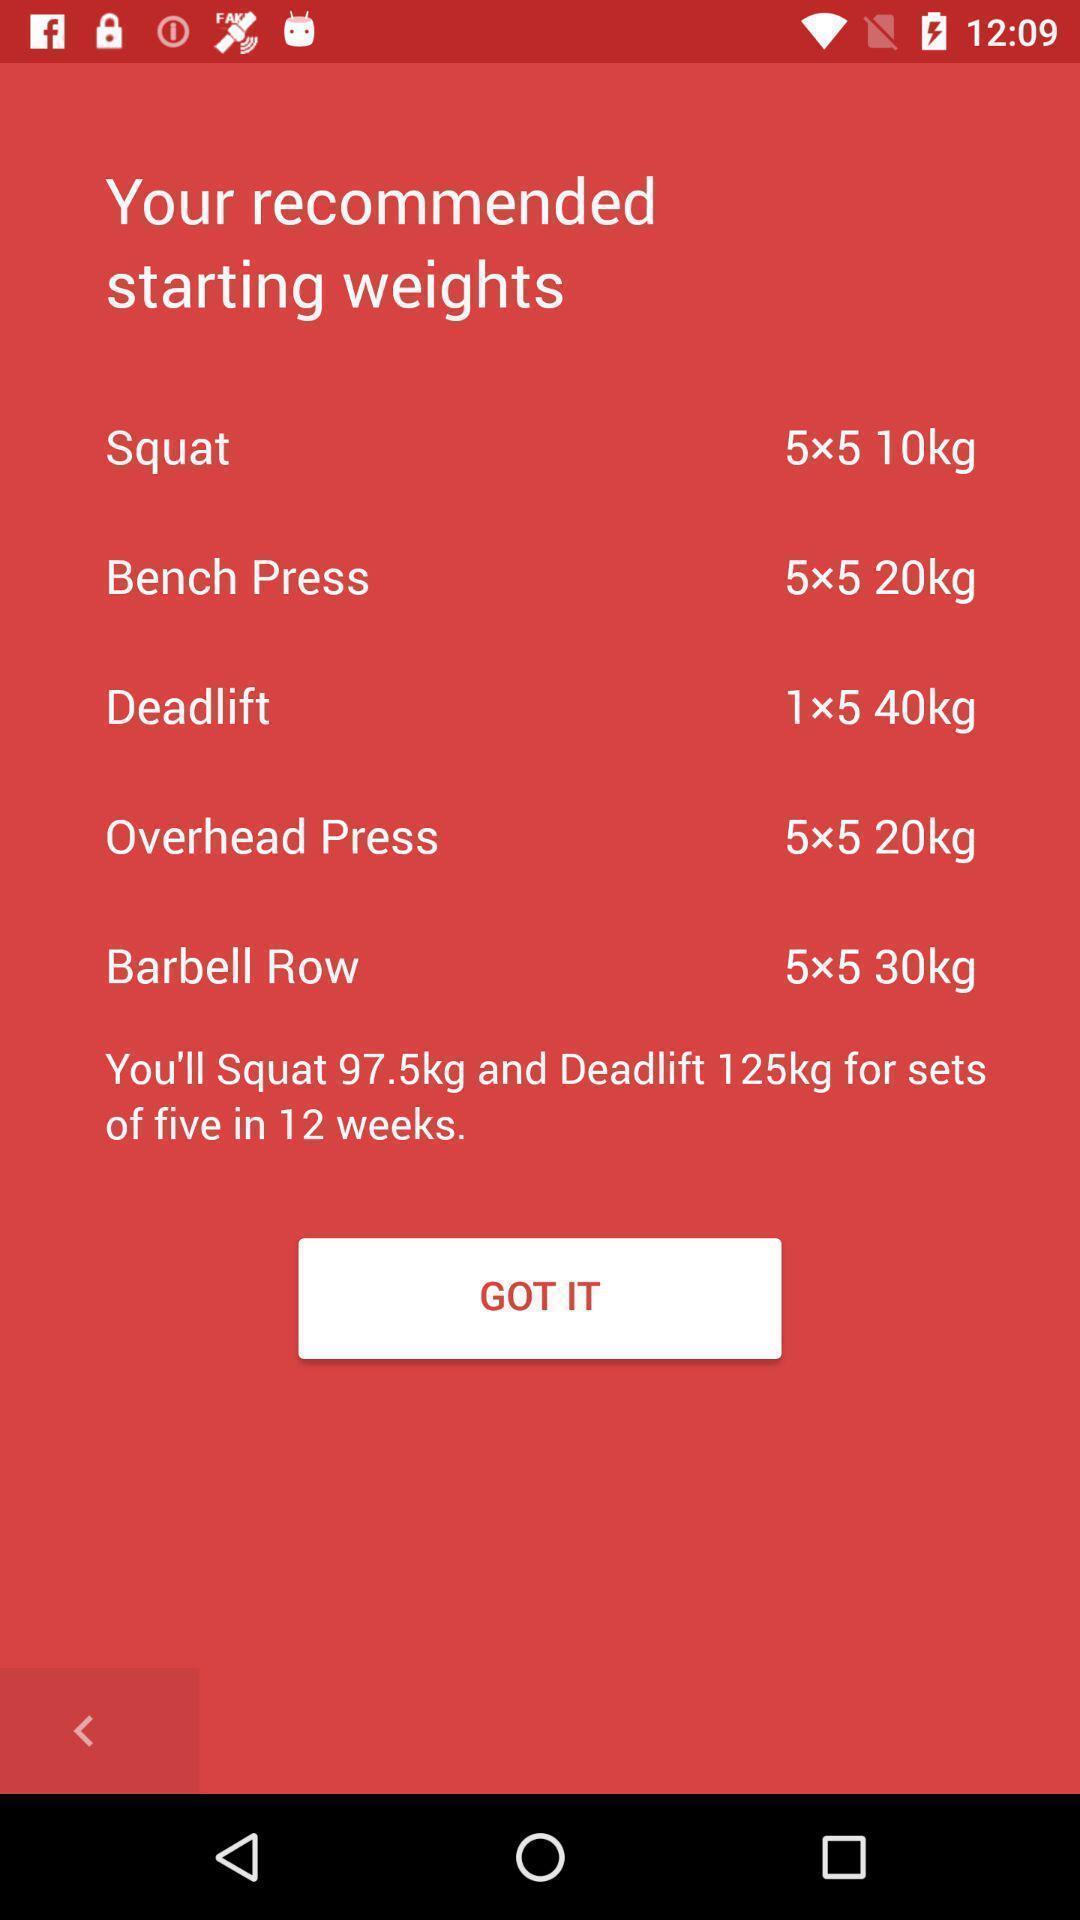Give me a summary of this screen capture. Screen showing recommended starting weights. 